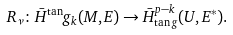<formula> <loc_0><loc_0><loc_500><loc_500>R _ { \nu } \colon \bar { H } ^ { \tan } g _ { k } ( M , E ) \to \bar { H } _ { \tan g } ^ { p - k } ( U , E ^ { * } ) .</formula> 